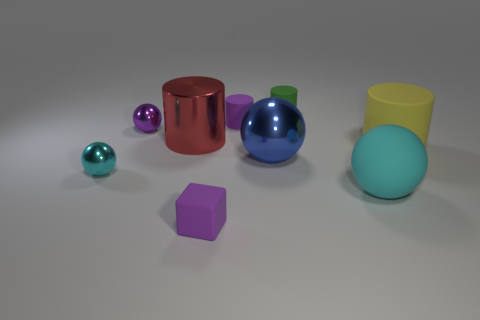How many cyan balls must be subtracted to get 1 cyan balls? 1 Subtract all yellow cylinders. How many cylinders are left? 3 Subtract all cylinders. How many objects are left? 5 Subtract all red cylinders. How many cylinders are left? 3 Subtract 2 balls. How many balls are left? 2 Subtract all red cylinders. How many blue spheres are left? 1 Add 3 gray balls. How many gray balls exist? 3 Subtract 1 blue spheres. How many objects are left? 8 Subtract all brown balls. Subtract all yellow blocks. How many balls are left? 4 Subtract all tiny spheres. Subtract all small purple balls. How many objects are left? 6 